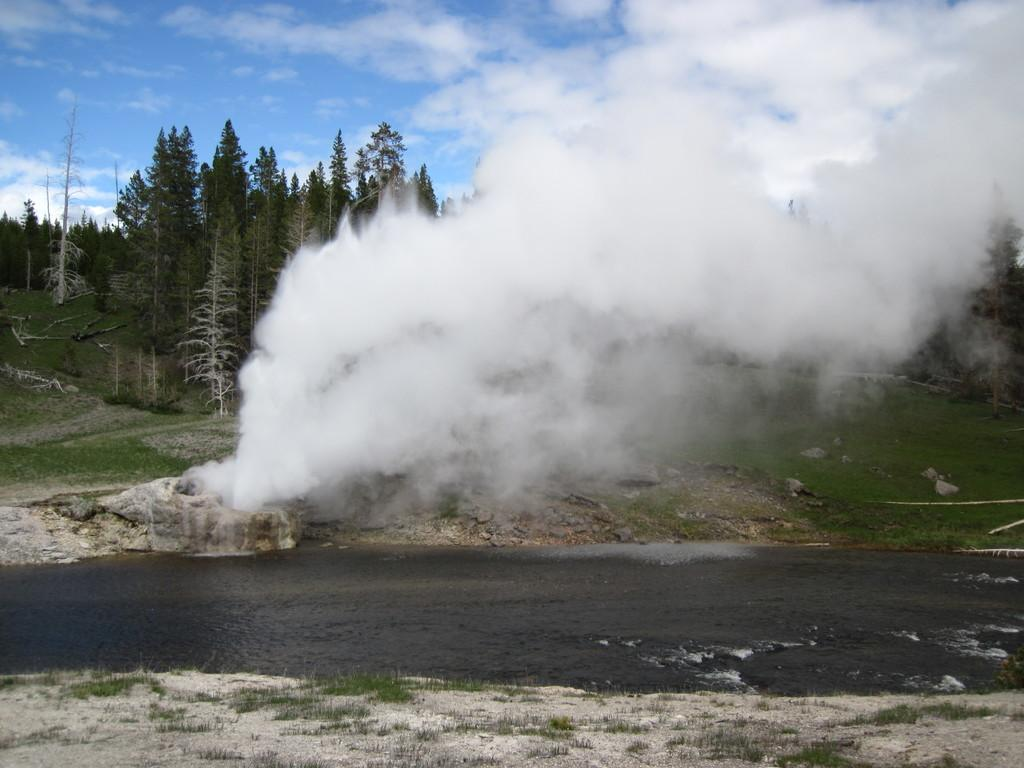What is visible in the image? Water, smoke, trees on a hill, and the sky are visible in the image. Can you describe the setting of the image? The image features a hill with trees, water, and smoke in the foreground, and the sky in the background. What might be the cause of the smoke visible in the image? The cause of the smoke is not explicitly mentioned in the facts, so it cannot be definitively determined. Where is the office located in the image? There is no office present in the image. Can you see a girl playing near the water in the image? There is no girl present in the image. 